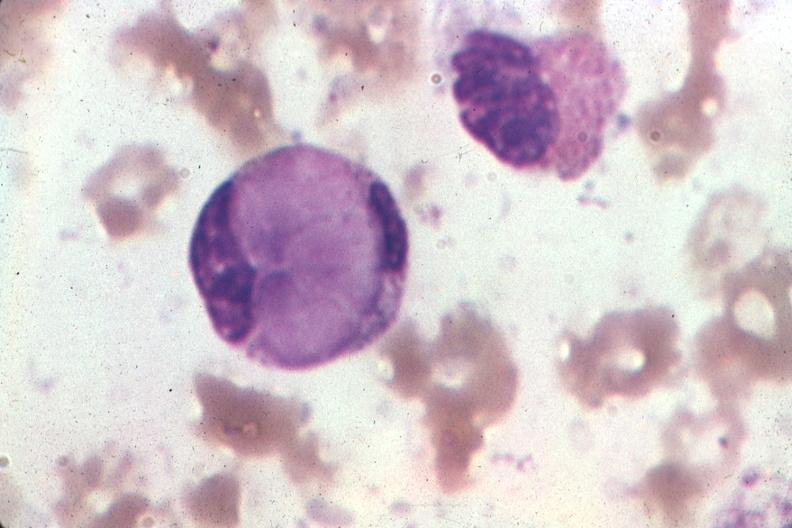what is present?
Answer the question using a single word or phrase. Hematologic 